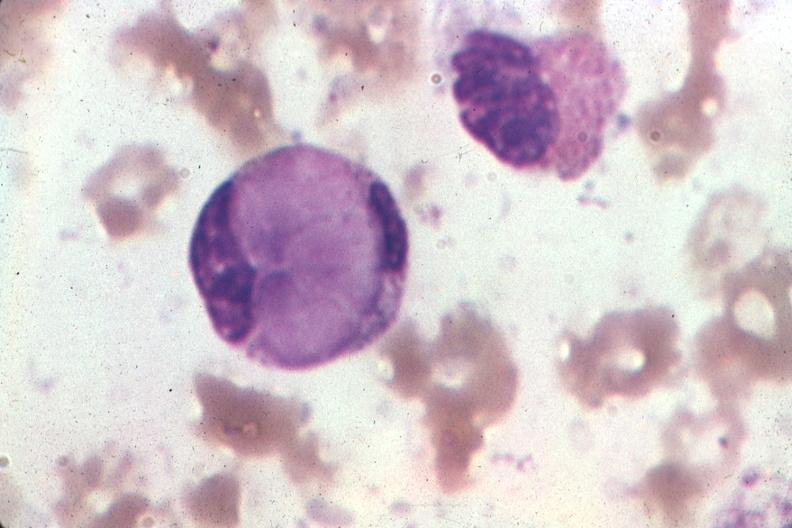what is present?
Answer the question using a single word or phrase. Hematologic 